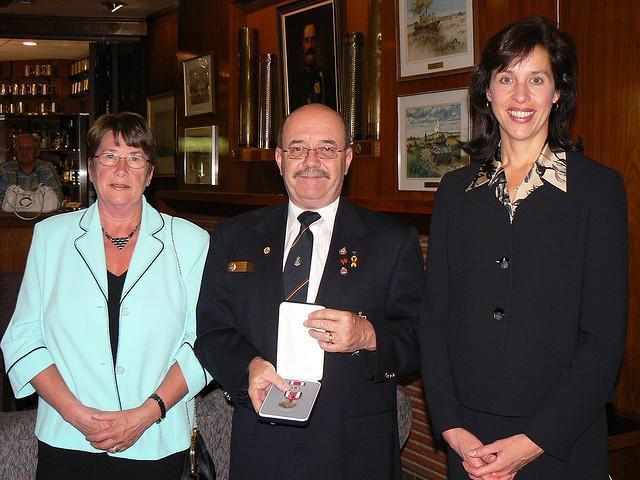How many people is in the photo?
Give a very brief answer. 3. How many males are in the scene?
Give a very brief answer. 1. How many people are there?
Give a very brief answer. 4. 